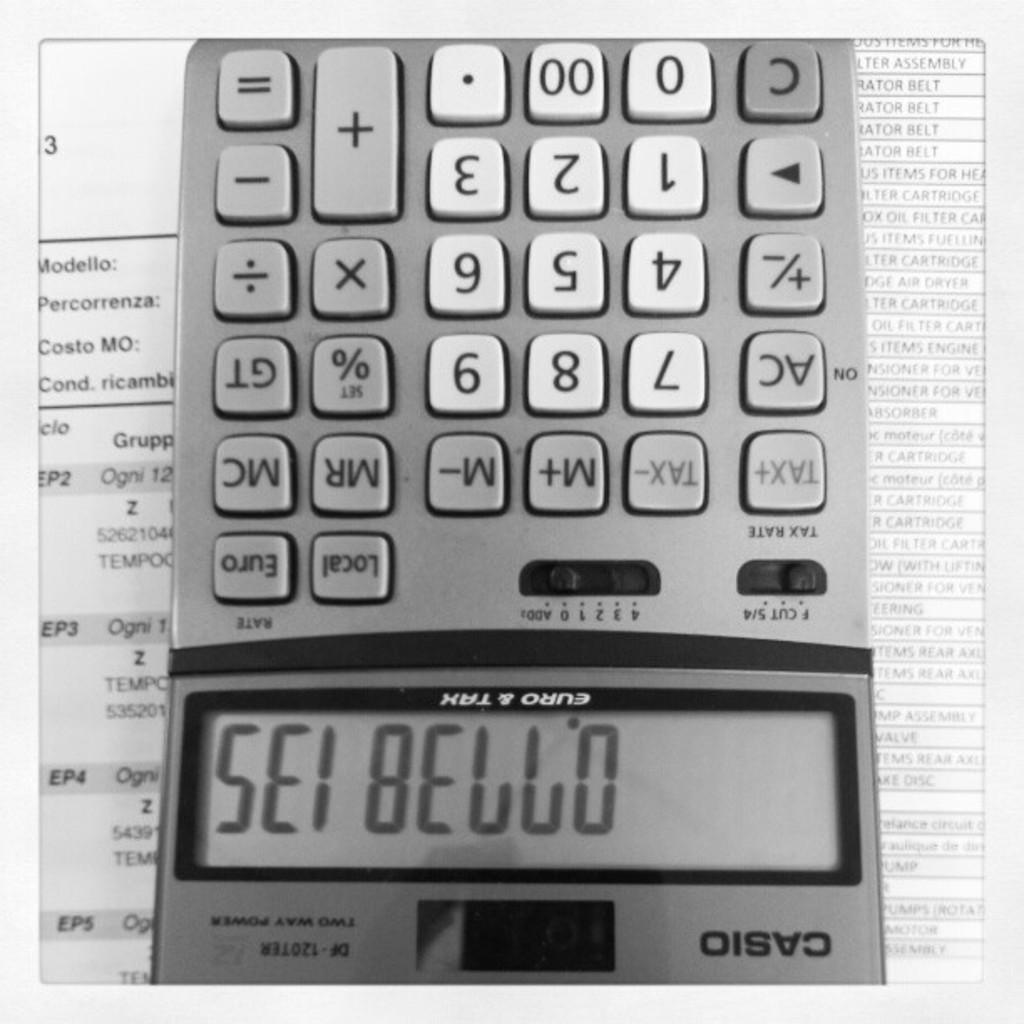Provide a one-sentence caption for the provided image. Sei Bello is written on a Casio calculator. 